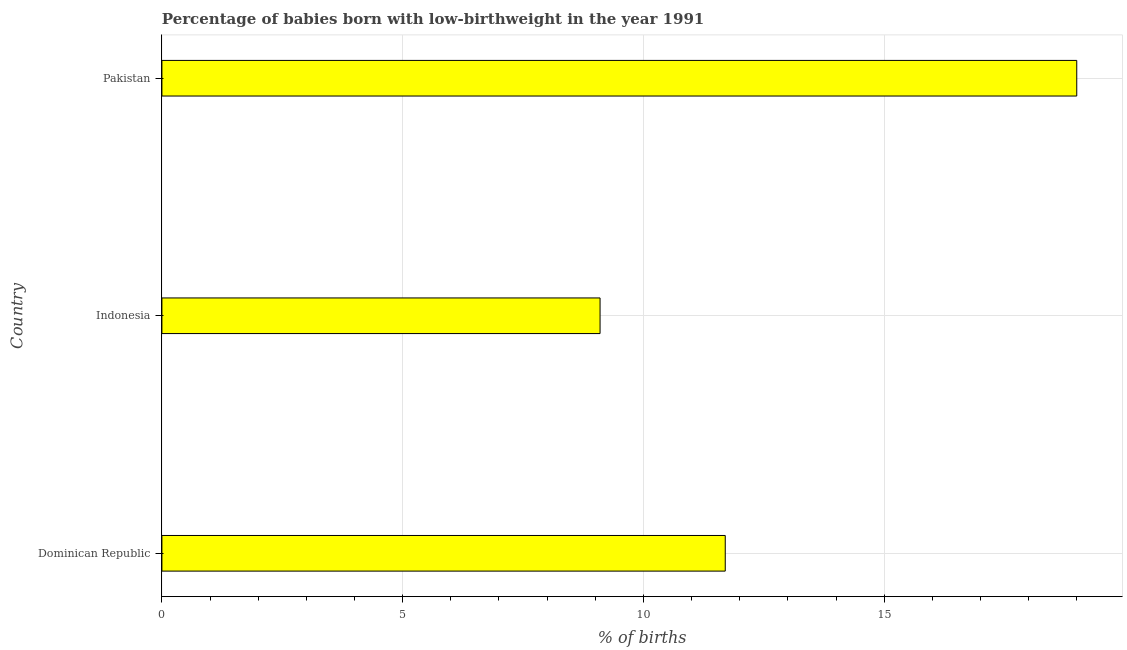Does the graph contain any zero values?
Make the answer very short. No. Does the graph contain grids?
Your answer should be very brief. Yes. What is the title of the graph?
Your response must be concise. Percentage of babies born with low-birthweight in the year 1991. What is the label or title of the X-axis?
Your response must be concise. % of births. What is the label or title of the Y-axis?
Ensure brevity in your answer.  Country. What is the percentage of babies who were born with low-birthweight in Dominican Republic?
Ensure brevity in your answer.  11.7. Across all countries, what is the maximum percentage of babies who were born with low-birthweight?
Make the answer very short. 19. Across all countries, what is the minimum percentage of babies who were born with low-birthweight?
Give a very brief answer. 9.1. In which country was the percentage of babies who were born with low-birthweight maximum?
Keep it short and to the point. Pakistan. In which country was the percentage of babies who were born with low-birthweight minimum?
Ensure brevity in your answer.  Indonesia. What is the sum of the percentage of babies who were born with low-birthweight?
Your answer should be very brief. 39.8. What is the difference between the percentage of babies who were born with low-birthweight in Dominican Republic and Pakistan?
Provide a succinct answer. -7.3. What is the average percentage of babies who were born with low-birthweight per country?
Make the answer very short. 13.27. What is the median percentage of babies who were born with low-birthweight?
Your answer should be very brief. 11.7. What is the ratio of the percentage of babies who were born with low-birthweight in Indonesia to that in Pakistan?
Your answer should be compact. 0.48. Is the percentage of babies who were born with low-birthweight in Dominican Republic less than that in Pakistan?
Make the answer very short. Yes. What is the difference between the highest and the lowest percentage of babies who were born with low-birthweight?
Give a very brief answer. 9.9. How many bars are there?
Give a very brief answer. 3. Are all the bars in the graph horizontal?
Keep it short and to the point. Yes. What is the difference between two consecutive major ticks on the X-axis?
Offer a terse response. 5. What is the % of births in Dominican Republic?
Ensure brevity in your answer.  11.7. What is the % of births of Indonesia?
Provide a short and direct response. 9.1. What is the % of births of Pakistan?
Provide a succinct answer. 19. What is the difference between the % of births in Dominican Republic and Pakistan?
Offer a very short reply. -7.3. What is the difference between the % of births in Indonesia and Pakistan?
Ensure brevity in your answer.  -9.9. What is the ratio of the % of births in Dominican Republic to that in Indonesia?
Your answer should be compact. 1.29. What is the ratio of the % of births in Dominican Republic to that in Pakistan?
Give a very brief answer. 0.62. What is the ratio of the % of births in Indonesia to that in Pakistan?
Your answer should be compact. 0.48. 